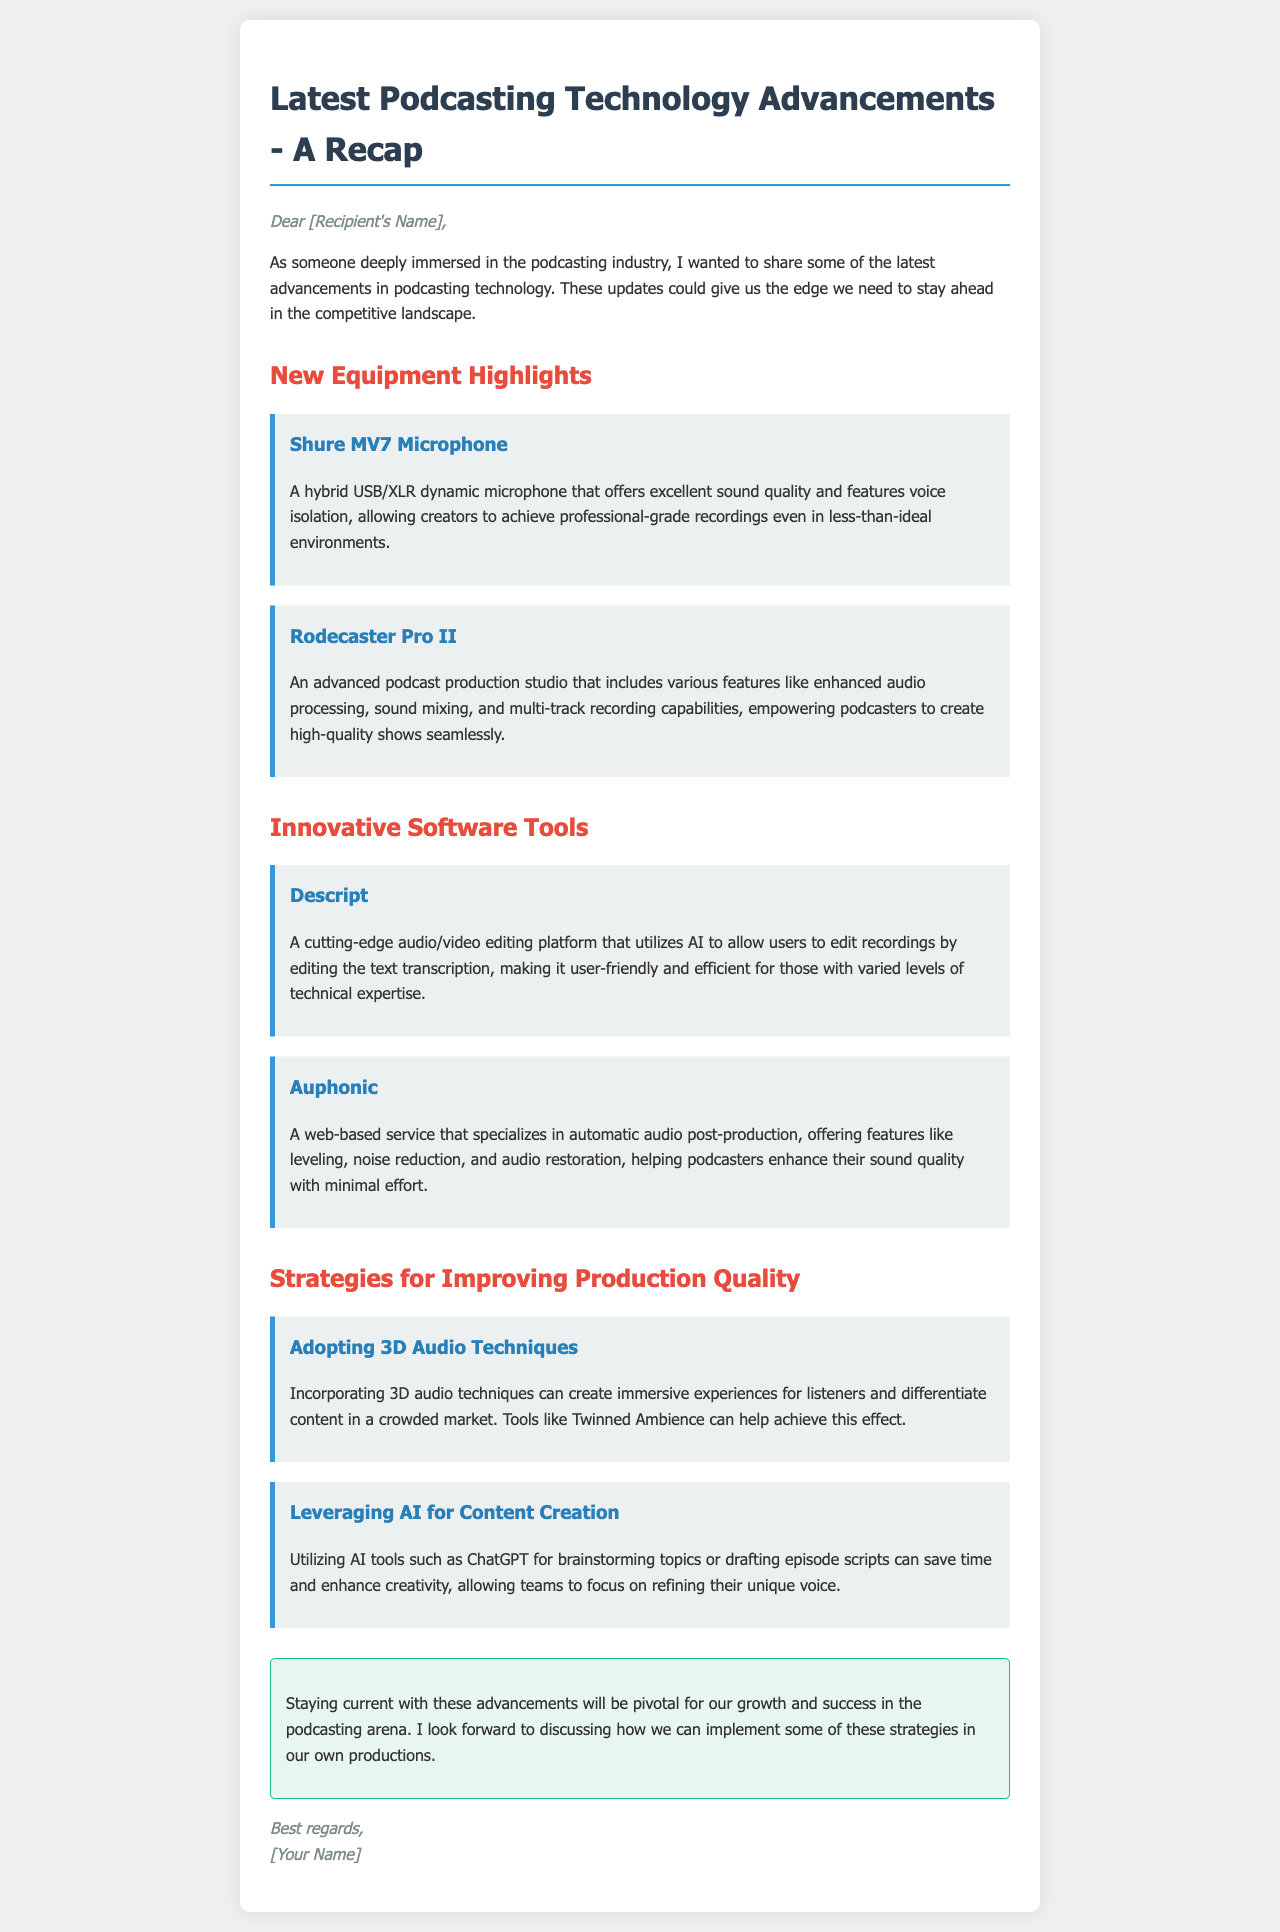What is the title of the document? The title is found at the top of the document, summarizing its main subject.
Answer: Latest Podcasting Technology Advancements - A Recap Who is the first new equipment highlighted? The first equipment mentioned in the document provides specific details about a microphone.
Answer: Shure MV7 Microphone What innovative software tool is used for audio/video editing? The document lists a software tool that is known for its AI-assisted features in editing.
Answer: Descript What audio production technique is recommended? The document suggests a technique that can enhance listener experience within the production section.
Answer: 3D Audio Techniques Which service specializes in automatic audio post-production? This question targets a specific tool mentioned for enhancing sound quality in the document.
Answer: Auphonic How does the document suggest utilizing AI in content creation? This question refers to the strategy discussed for improving the podcasting process through technological means.
Answer: Brainstorming topics or drafting episode scripts What is a key benefit of the Rodecaster Pro II? The document highlights features of this equipment within the context of production capabilities.
Answer: Enhanced audio processing What essential strategy is mentioned for staying competitive? This question is directed at the overarching theme of the document concerning future growth.
Answer: Staying current with advancements What is the tone of the closing? The closing remarks provide an emotional and professional tone, wrapping up the main content.
Answer: Best regards 